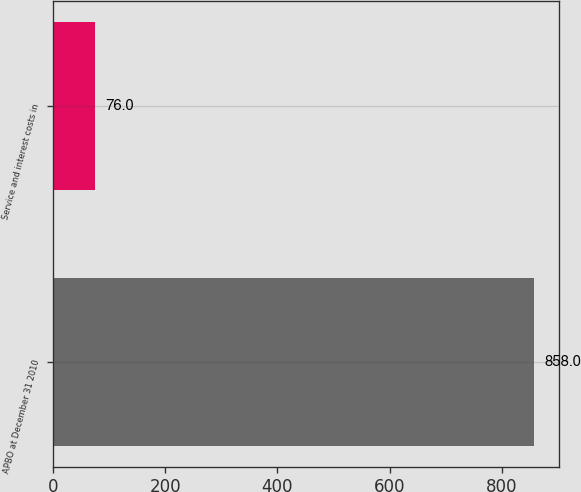Convert chart. <chart><loc_0><loc_0><loc_500><loc_500><bar_chart><fcel>APBO at December 31 2010<fcel>Service and interest costs in<nl><fcel>858<fcel>76<nl></chart> 